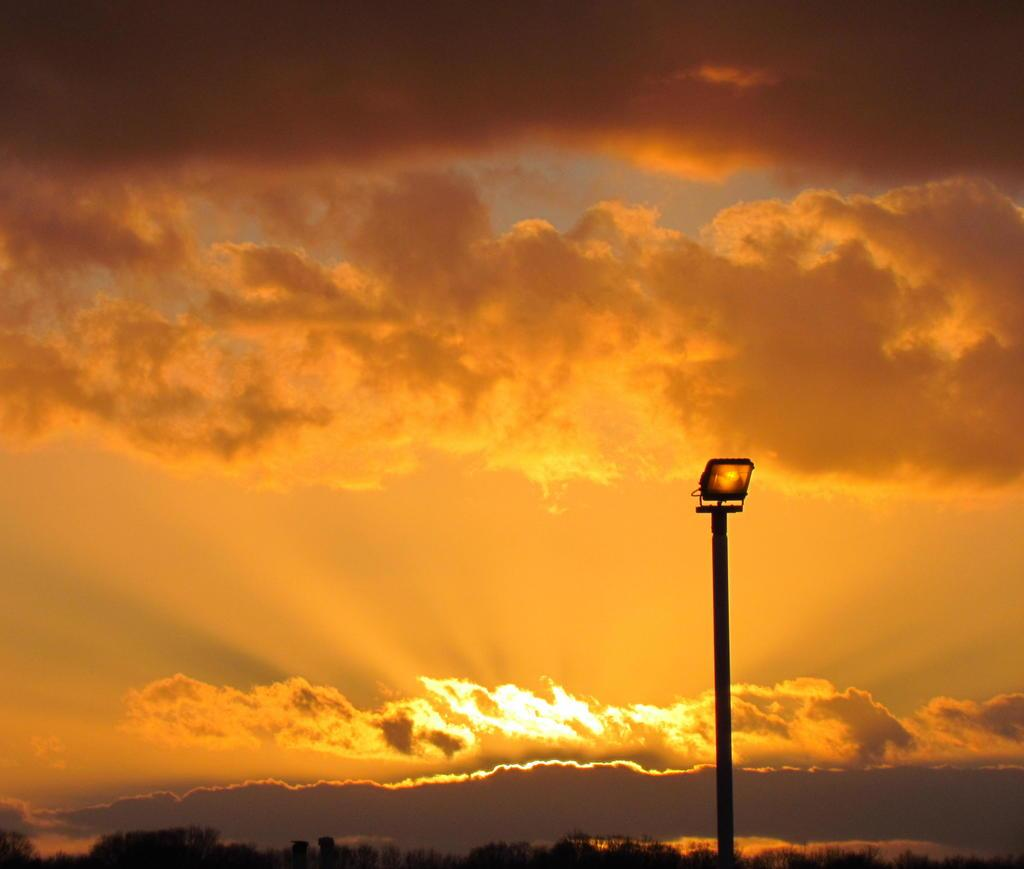What type of structure is present in the image? There is a street light in the image. What other natural elements can be seen in the image? There are trees in the image. What is visible in the background of the image? The sky is visible in the image. What type of pump is attached to the street light in the image? There is no pump present in the image; it only features a street light, trees, and the sky. What finger is pointing at the street light in the image? There are no fingers or people present in the image, so it is not possible to determine if any fingers are pointing at the street light. 